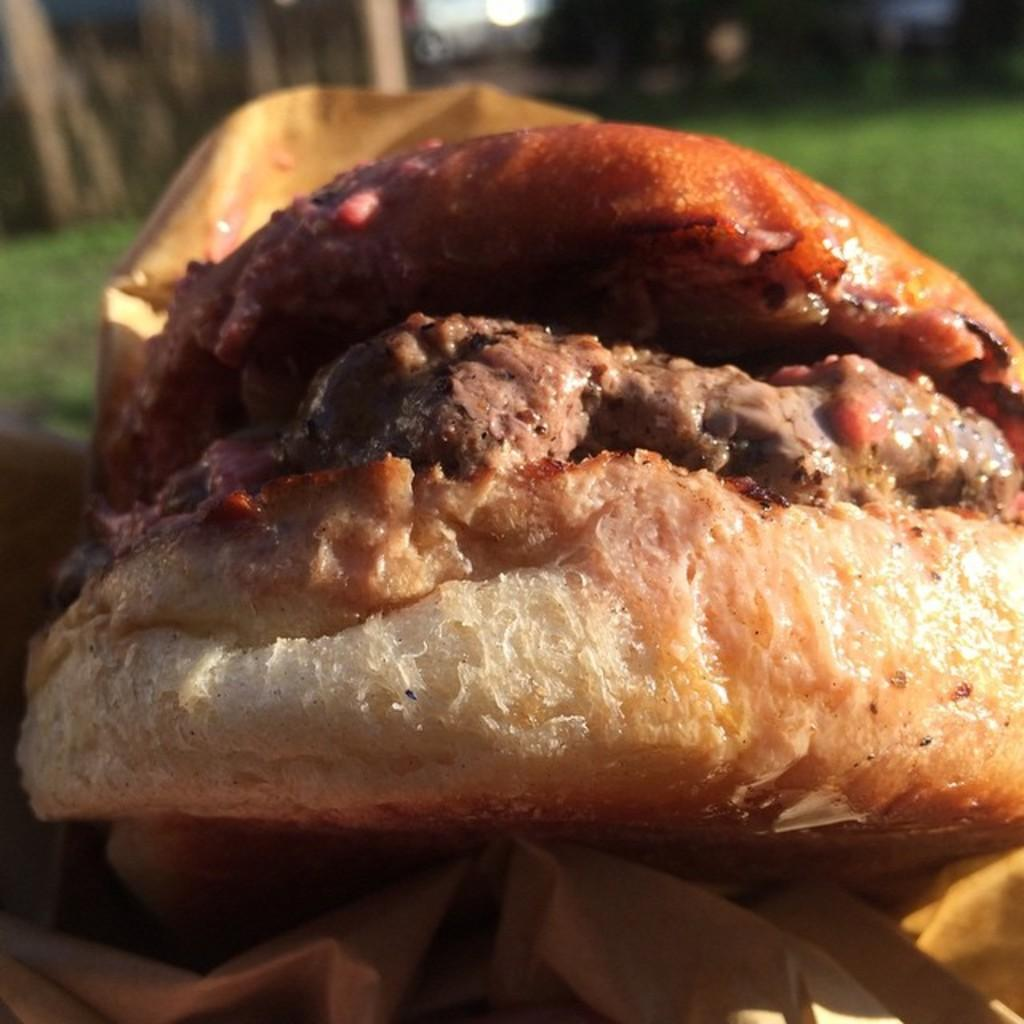What type of food is shown in the image? There is a burger in the image. What accompanies the burger in the image? There is sauce on the burger. What color mixture is visible in the image? There is a brown color mixture in the image. What type of books can be found in the library depicted in the image? There is no library present in the image; it features a burger with sauce and a brown color mixture. 